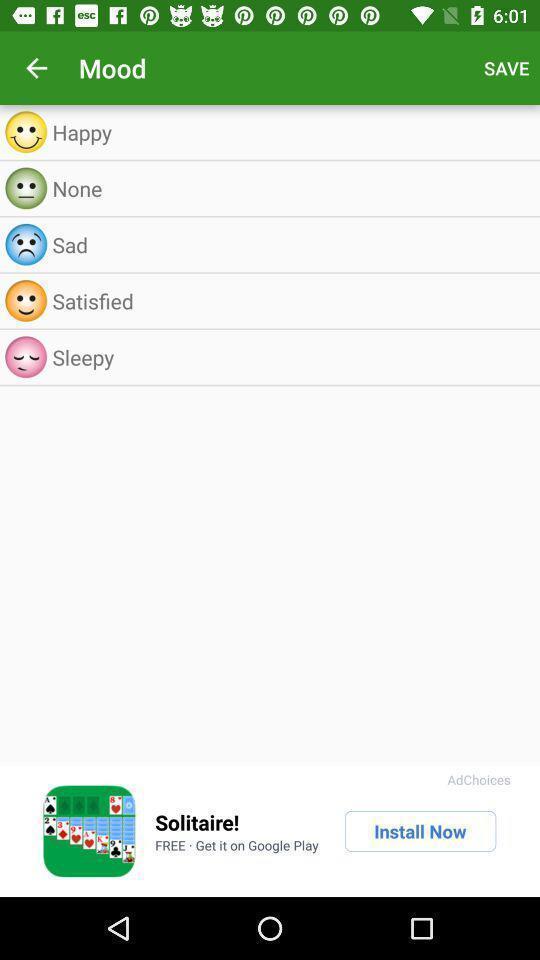Summarize the information in this screenshot. Screen shows different moods. 